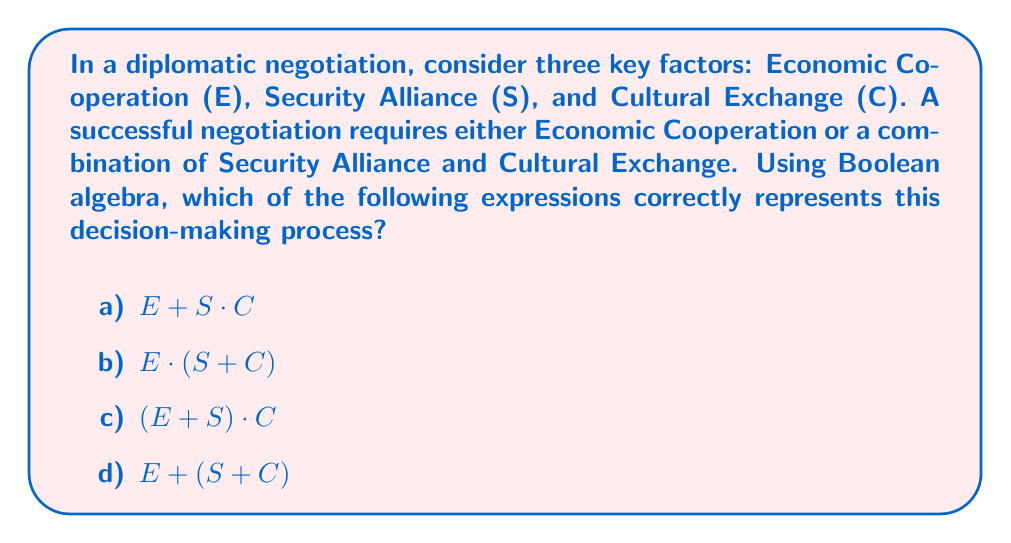Give your solution to this math problem. Let's approach this step-by-step using Boolean algebra:

1) We need to represent "Economic Cooperation OR (Security Alliance AND Cultural Exchange)".

2) In Boolean algebra:
   - OR is represented by $+$
   - AND is represented by $\cdot$ or simply by juxtaposition

3) So, we can express our condition as:
   $E + (S \cdot C)$

4) Now, let's analyze each option:

   a) $E + S \cdot C$
      This is the correct expression. It accurately represents "Economic Cooperation OR (Security Alliance AND Cultural Exchange)".

   b) $E \cdot (S + C)$
      This represents "(Economic Cooperation AND Security Alliance) OR (Economic Cooperation AND Cultural Exchange)", which is not what we want.

   c) $(E + S) \cdot C$
      This represents "(Economic Cooperation OR Security Alliance) AND Cultural Exchange", which is also incorrect.

   d) $E + (S + C)$
      This represents "Economic Cooperation OR Security Alliance OR Cultural Exchange", which doesn't capture the required AND between Security Alliance and Cultural Exchange.

5) Therefore, the correct answer is option a) $E + S \cdot C$.
Answer: a) $E + S \cdot C$ 